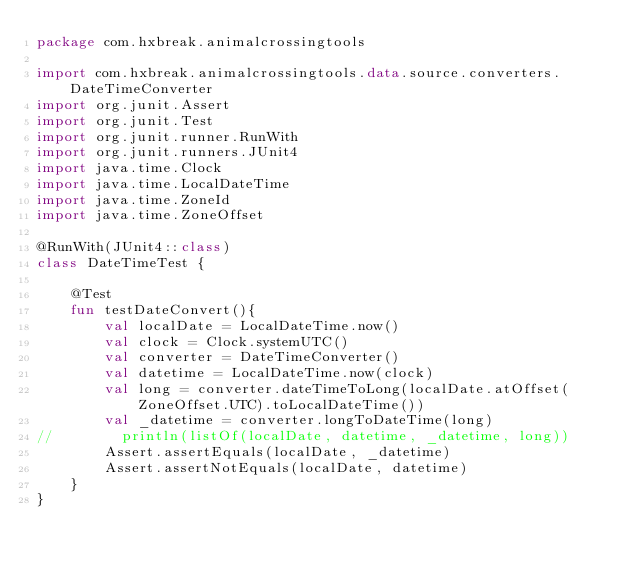<code> <loc_0><loc_0><loc_500><loc_500><_Kotlin_>package com.hxbreak.animalcrossingtools

import com.hxbreak.animalcrossingtools.data.source.converters.DateTimeConverter
import org.junit.Assert
import org.junit.Test
import org.junit.runner.RunWith
import org.junit.runners.JUnit4
import java.time.Clock
import java.time.LocalDateTime
import java.time.ZoneId
import java.time.ZoneOffset

@RunWith(JUnit4::class)
class DateTimeTest {

    @Test
    fun testDateConvert(){
        val localDate = LocalDateTime.now()
        val clock = Clock.systemUTC()
        val converter = DateTimeConverter()
        val datetime = LocalDateTime.now(clock)
        val long = converter.dateTimeToLong(localDate.atOffset(ZoneOffset.UTC).toLocalDateTime())
        val _datetime = converter.longToDateTime(long)
//        println(listOf(localDate, datetime, _datetime, long))
        Assert.assertEquals(localDate, _datetime)
        Assert.assertNotEquals(localDate, datetime)
    }
}</code> 